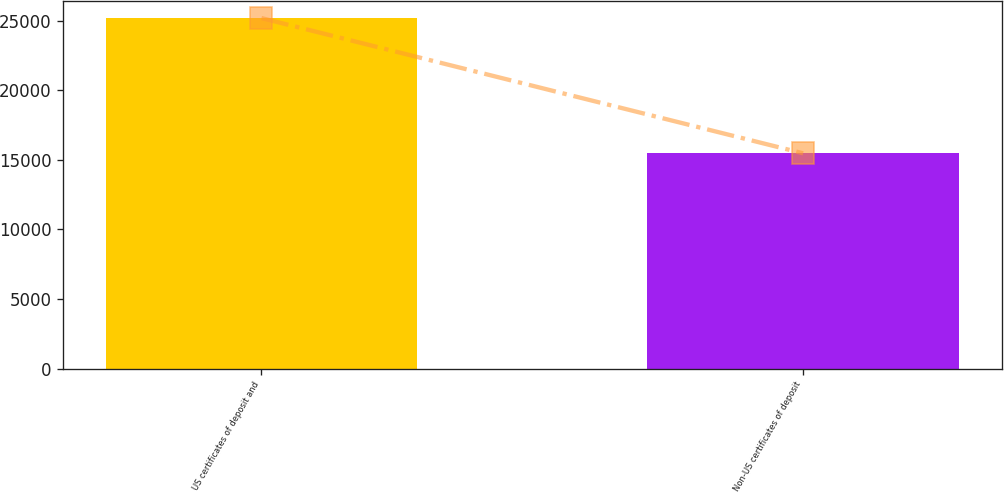<chart> <loc_0><loc_0><loc_500><loc_500><bar_chart><fcel>US certificates of deposit and<fcel>Non-US certificates of deposit<nl><fcel>25192<fcel>15472<nl></chart> 